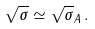Convert formula to latex. <formula><loc_0><loc_0><loc_500><loc_500>\sqrt { \sigma } \simeq \sqrt { \sigma } _ { A } \, .</formula> 